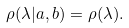<formula> <loc_0><loc_0><loc_500><loc_500>\rho ( \lambda | a , b ) = \rho ( \lambda ) .</formula> 